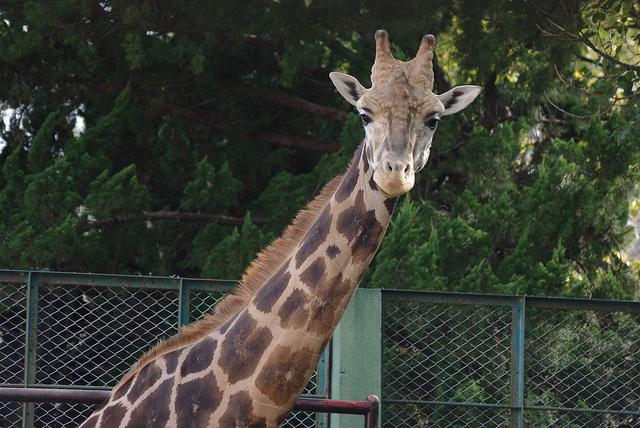What is the giraffe grazing on?
Concise answer only. Leaves. Is the giraffe in the wild?
Keep it brief. No. Is this giraffe in its natural habitat?
Answer briefly. No. Is the giraffe eating or drinking?
Keep it brief. No. Is the giraffe looking at the camera?
Short answer required. Yes. What animal is shown here?
Short answer required. Giraffe. How many giraffes are there?
Give a very brief answer. 1. Does this giraffe have stubs for horns?
Answer briefly. Yes. 